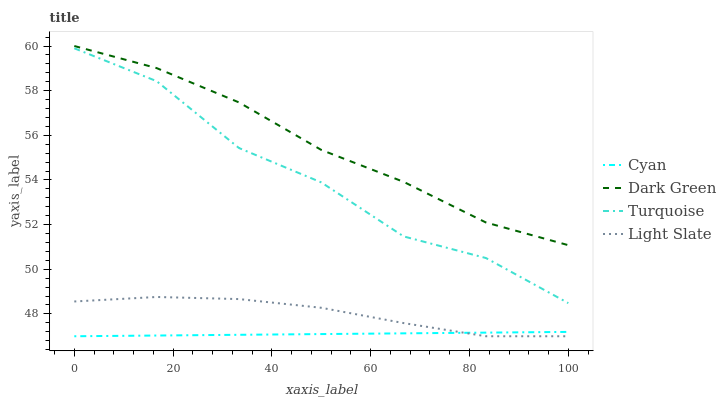Does Cyan have the minimum area under the curve?
Answer yes or no. Yes. Does Dark Green have the maximum area under the curve?
Answer yes or no. Yes. Does Turquoise have the minimum area under the curve?
Answer yes or no. No. Does Turquoise have the maximum area under the curve?
Answer yes or no. No. Is Cyan the smoothest?
Answer yes or no. Yes. Is Turquoise the roughest?
Answer yes or no. Yes. Is Turquoise the smoothest?
Answer yes or no. No. Is Cyan the roughest?
Answer yes or no. No. Does Turquoise have the lowest value?
Answer yes or no. No. Does Turquoise have the highest value?
Answer yes or no. No. Is Turquoise less than Dark Green?
Answer yes or no. Yes. Is Dark Green greater than Turquoise?
Answer yes or no. Yes. Does Turquoise intersect Dark Green?
Answer yes or no. No. 